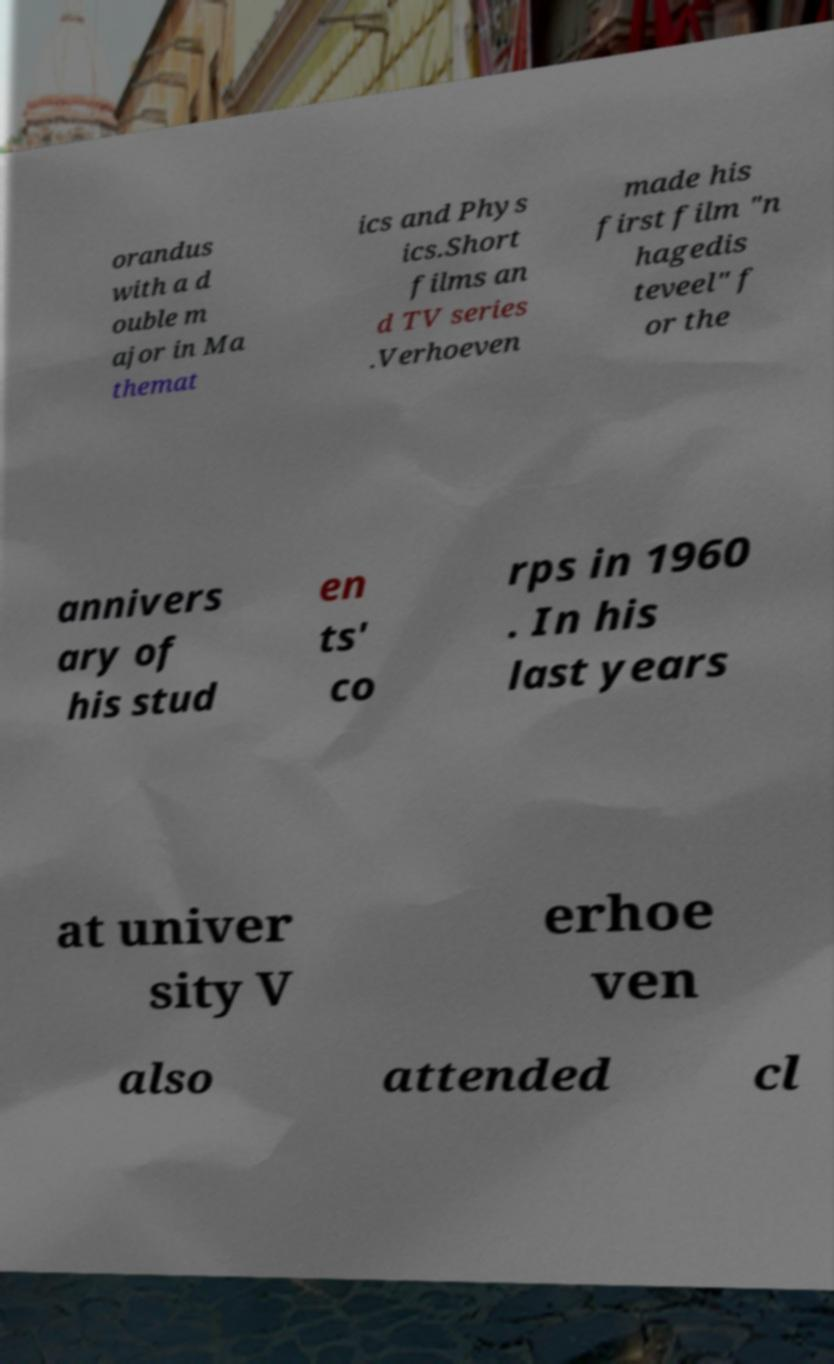Could you extract and type out the text from this image? orandus with a d ouble m ajor in Ma themat ics and Phys ics.Short films an d TV series .Verhoeven made his first film "n hagedis teveel" f or the annivers ary of his stud en ts' co rps in 1960 . In his last years at univer sity V erhoe ven also attended cl 